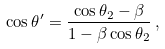<formula> <loc_0><loc_0><loc_500><loc_500>\cos \theta ^ { \prime } = \frac { \cos \theta _ { 2 } - \beta } { 1 - \beta \cos \theta _ { 2 } } \, ,</formula> 